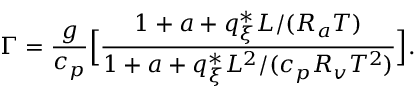<formula> <loc_0><loc_0><loc_500><loc_500>\Gamma = \frac { g } { c _ { p } } \left [ \frac { 1 + a + q _ { \xi } ^ { * } L / ( R _ { a } T ) } { 1 + a + q _ { \xi } ^ { * } L ^ { 2 } / ( c _ { p } R _ { v } T ^ { 2 } ) } \right ] .</formula> 